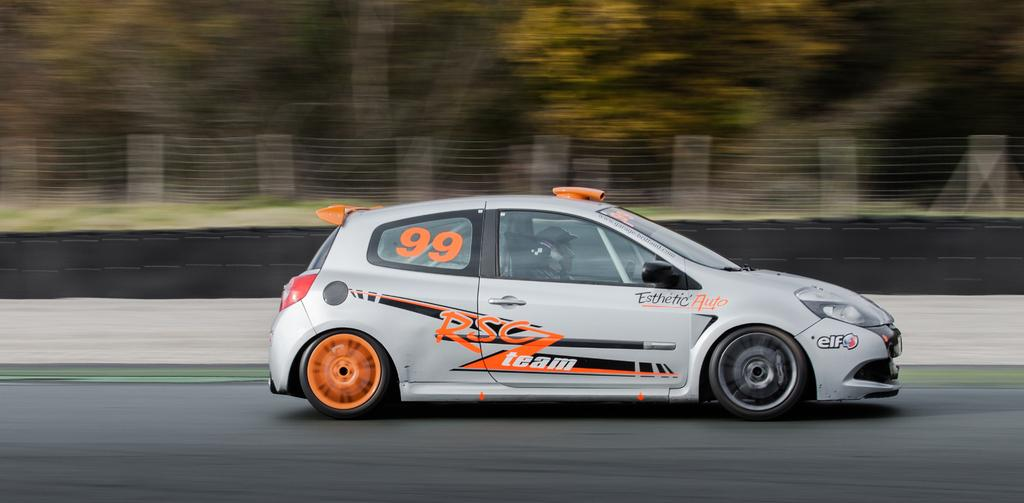How many people are in the image? There are two persons in the image. What are the persons wearing on their heads? The persons are wearing helmets. Where are the persons located in the image? The persons are sitting inside a car. What can be seen at the bottom of the image? There is a road visible at the bottom of the image. What is visible in the background of the image? There is fencing, trees, and grass in the background of the image. What type of yam is being served in the image? There is no yam present in the image. 